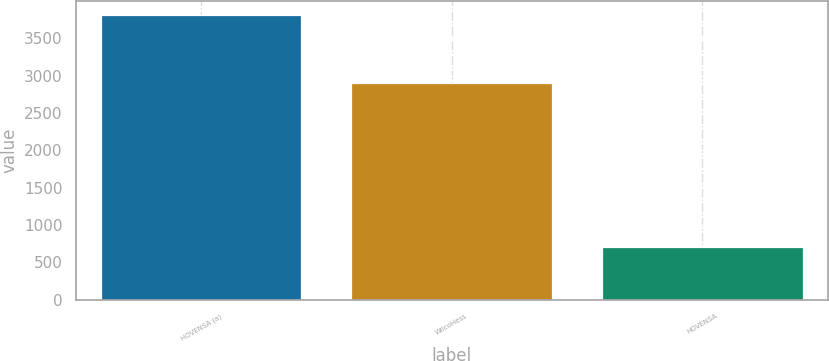Convert chart. <chart><loc_0><loc_0><loc_500><loc_500><bar_chart><fcel>HOVENSA (a)<fcel>WilcoHess<fcel>HOVENSA<nl><fcel>3806<fcel>2898<fcel>710<nl></chart> 